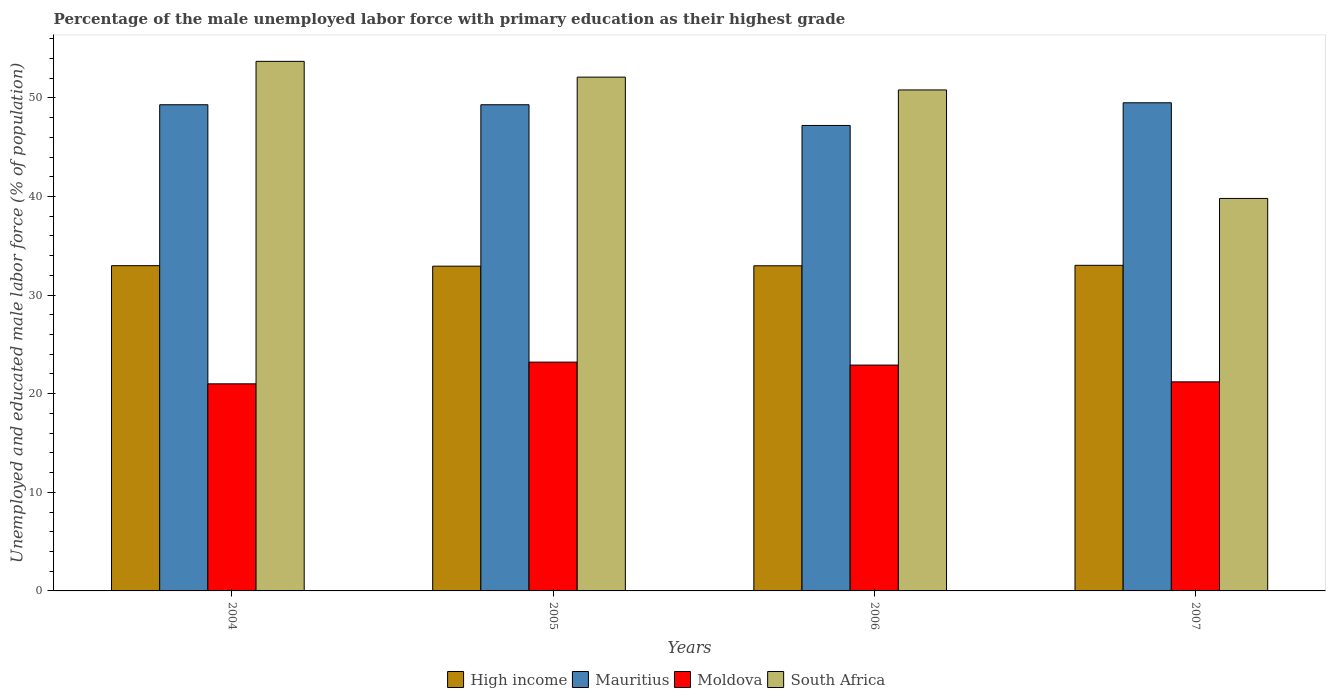Are the number of bars per tick equal to the number of legend labels?
Offer a very short reply. Yes. What is the percentage of the unemployed male labor force with primary education in South Africa in 2007?
Your answer should be compact. 39.8. Across all years, what is the maximum percentage of the unemployed male labor force with primary education in South Africa?
Your response must be concise. 53.7. Across all years, what is the minimum percentage of the unemployed male labor force with primary education in Mauritius?
Your response must be concise. 47.2. What is the total percentage of the unemployed male labor force with primary education in South Africa in the graph?
Give a very brief answer. 196.4. What is the difference between the percentage of the unemployed male labor force with primary education in South Africa in 2005 and that in 2007?
Your answer should be compact. 12.3. What is the difference between the percentage of the unemployed male labor force with primary education in South Africa in 2007 and the percentage of the unemployed male labor force with primary education in Mauritius in 2006?
Ensure brevity in your answer.  -7.4. What is the average percentage of the unemployed male labor force with primary education in South Africa per year?
Your answer should be compact. 49.1. In the year 2004, what is the difference between the percentage of the unemployed male labor force with primary education in South Africa and percentage of the unemployed male labor force with primary education in Mauritius?
Your response must be concise. 4.4. In how many years, is the percentage of the unemployed male labor force with primary education in High income greater than 12 %?
Provide a short and direct response. 4. What is the ratio of the percentage of the unemployed male labor force with primary education in Moldova in 2004 to that in 2006?
Offer a very short reply. 0.92. Is the difference between the percentage of the unemployed male labor force with primary education in South Africa in 2006 and 2007 greater than the difference between the percentage of the unemployed male labor force with primary education in Mauritius in 2006 and 2007?
Your answer should be very brief. Yes. What is the difference between the highest and the second highest percentage of the unemployed male labor force with primary education in Mauritius?
Provide a succinct answer. 0.2. What is the difference between the highest and the lowest percentage of the unemployed male labor force with primary education in High income?
Give a very brief answer. 0.09. In how many years, is the percentage of the unemployed male labor force with primary education in High income greater than the average percentage of the unemployed male labor force with primary education in High income taken over all years?
Provide a succinct answer. 2. Is it the case that in every year, the sum of the percentage of the unemployed male labor force with primary education in High income and percentage of the unemployed male labor force with primary education in Mauritius is greater than the sum of percentage of the unemployed male labor force with primary education in South Africa and percentage of the unemployed male labor force with primary education in Moldova?
Give a very brief answer. No. What does the 4th bar from the left in 2007 represents?
Offer a very short reply. South Africa. What does the 2nd bar from the right in 2004 represents?
Keep it short and to the point. Moldova. Are all the bars in the graph horizontal?
Provide a short and direct response. No. What is the difference between two consecutive major ticks on the Y-axis?
Provide a succinct answer. 10. Are the values on the major ticks of Y-axis written in scientific E-notation?
Your response must be concise. No. How many legend labels are there?
Give a very brief answer. 4. What is the title of the graph?
Offer a very short reply. Percentage of the male unemployed labor force with primary education as their highest grade. What is the label or title of the X-axis?
Offer a very short reply. Years. What is the label or title of the Y-axis?
Your response must be concise. Unemployed and educated male labor force (% of population). What is the Unemployed and educated male labor force (% of population) of High income in 2004?
Provide a short and direct response. 32.98. What is the Unemployed and educated male labor force (% of population) in Mauritius in 2004?
Make the answer very short. 49.3. What is the Unemployed and educated male labor force (% of population) in South Africa in 2004?
Provide a short and direct response. 53.7. What is the Unemployed and educated male labor force (% of population) in High income in 2005?
Your answer should be very brief. 32.93. What is the Unemployed and educated male labor force (% of population) in Mauritius in 2005?
Offer a very short reply. 49.3. What is the Unemployed and educated male labor force (% of population) of Moldova in 2005?
Make the answer very short. 23.2. What is the Unemployed and educated male labor force (% of population) in South Africa in 2005?
Provide a short and direct response. 52.1. What is the Unemployed and educated male labor force (% of population) of High income in 2006?
Give a very brief answer. 32.97. What is the Unemployed and educated male labor force (% of population) in Mauritius in 2006?
Your response must be concise. 47.2. What is the Unemployed and educated male labor force (% of population) in Moldova in 2006?
Offer a terse response. 22.9. What is the Unemployed and educated male labor force (% of population) of South Africa in 2006?
Provide a succinct answer. 50.8. What is the Unemployed and educated male labor force (% of population) of High income in 2007?
Keep it short and to the point. 33.02. What is the Unemployed and educated male labor force (% of population) in Mauritius in 2007?
Your response must be concise. 49.5. What is the Unemployed and educated male labor force (% of population) in Moldova in 2007?
Ensure brevity in your answer.  21.2. What is the Unemployed and educated male labor force (% of population) of South Africa in 2007?
Provide a short and direct response. 39.8. Across all years, what is the maximum Unemployed and educated male labor force (% of population) of High income?
Offer a very short reply. 33.02. Across all years, what is the maximum Unemployed and educated male labor force (% of population) in Mauritius?
Provide a short and direct response. 49.5. Across all years, what is the maximum Unemployed and educated male labor force (% of population) in Moldova?
Make the answer very short. 23.2. Across all years, what is the maximum Unemployed and educated male labor force (% of population) in South Africa?
Provide a short and direct response. 53.7. Across all years, what is the minimum Unemployed and educated male labor force (% of population) of High income?
Give a very brief answer. 32.93. Across all years, what is the minimum Unemployed and educated male labor force (% of population) of Mauritius?
Your answer should be compact. 47.2. Across all years, what is the minimum Unemployed and educated male labor force (% of population) in Moldova?
Keep it short and to the point. 21. Across all years, what is the minimum Unemployed and educated male labor force (% of population) in South Africa?
Make the answer very short. 39.8. What is the total Unemployed and educated male labor force (% of population) in High income in the graph?
Your answer should be compact. 131.9. What is the total Unemployed and educated male labor force (% of population) in Mauritius in the graph?
Give a very brief answer. 195.3. What is the total Unemployed and educated male labor force (% of population) in Moldova in the graph?
Provide a succinct answer. 88.3. What is the total Unemployed and educated male labor force (% of population) of South Africa in the graph?
Keep it short and to the point. 196.4. What is the difference between the Unemployed and educated male labor force (% of population) of High income in 2004 and that in 2005?
Make the answer very short. 0.05. What is the difference between the Unemployed and educated male labor force (% of population) in Moldova in 2004 and that in 2005?
Make the answer very short. -2.2. What is the difference between the Unemployed and educated male labor force (% of population) in South Africa in 2004 and that in 2005?
Keep it short and to the point. 1.6. What is the difference between the Unemployed and educated male labor force (% of population) in High income in 2004 and that in 2006?
Offer a very short reply. 0.01. What is the difference between the Unemployed and educated male labor force (% of population) in Mauritius in 2004 and that in 2006?
Your response must be concise. 2.1. What is the difference between the Unemployed and educated male labor force (% of population) in High income in 2004 and that in 2007?
Ensure brevity in your answer.  -0.04. What is the difference between the Unemployed and educated male labor force (% of population) of Mauritius in 2004 and that in 2007?
Keep it short and to the point. -0.2. What is the difference between the Unemployed and educated male labor force (% of population) in Moldova in 2004 and that in 2007?
Make the answer very short. -0.2. What is the difference between the Unemployed and educated male labor force (% of population) of South Africa in 2004 and that in 2007?
Your answer should be compact. 13.9. What is the difference between the Unemployed and educated male labor force (% of population) in High income in 2005 and that in 2006?
Provide a short and direct response. -0.04. What is the difference between the Unemployed and educated male labor force (% of population) in Moldova in 2005 and that in 2006?
Give a very brief answer. 0.3. What is the difference between the Unemployed and educated male labor force (% of population) of South Africa in 2005 and that in 2006?
Your answer should be very brief. 1.3. What is the difference between the Unemployed and educated male labor force (% of population) in High income in 2005 and that in 2007?
Provide a short and direct response. -0.09. What is the difference between the Unemployed and educated male labor force (% of population) of Moldova in 2005 and that in 2007?
Offer a very short reply. 2. What is the difference between the Unemployed and educated male labor force (% of population) in High income in 2006 and that in 2007?
Make the answer very short. -0.05. What is the difference between the Unemployed and educated male labor force (% of population) of Mauritius in 2006 and that in 2007?
Your answer should be very brief. -2.3. What is the difference between the Unemployed and educated male labor force (% of population) in High income in 2004 and the Unemployed and educated male labor force (% of population) in Mauritius in 2005?
Offer a very short reply. -16.32. What is the difference between the Unemployed and educated male labor force (% of population) in High income in 2004 and the Unemployed and educated male labor force (% of population) in Moldova in 2005?
Ensure brevity in your answer.  9.78. What is the difference between the Unemployed and educated male labor force (% of population) in High income in 2004 and the Unemployed and educated male labor force (% of population) in South Africa in 2005?
Your answer should be compact. -19.12. What is the difference between the Unemployed and educated male labor force (% of population) in Mauritius in 2004 and the Unemployed and educated male labor force (% of population) in Moldova in 2005?
Make the answer very short. 26.1. What is the difference between the Unemployed and educated male labor force (% of population) in Moldova in 2004 and the Unemployed and educated male labor force (% of population) in South Africa in 2005?
Your response must be concise. -31.1. What is the difference between the Unemployed and educated male labor force (% of population) in High income in 2004 and the Unemployed and educated male labor force (% of population) in Mauritius in 2006?
Ensure brevity in your answer.  -14.22. What is the difference between the Unemployed and educated male labor force (% of population) of High income in 2004 and the Unemployed and educated male labor force (% of population) of Moldova in 2006?
Give a very brief answer. 10.08. What is the difference between the Unemployed and educated male labor force (% of population) in High income in 2004 and the Unemployed and educated male labor force (% of population) in South Africa in 2006?
Provide a short and direct response. -17.82. What is the difference between the Unemployed and educated male labor force (% of population) of Mauritius in 2004 and the Unemployed and educated male labor force (% of population) of Moldova in 2006?
Your answer should be compact. 26.4. What is the difference between the Unemployed and educated male labor force (% of population) of Mauritius in 2004 and the Unemployed and educated male labor force (% of population) of South Africa in 2006?
Ensure brevity in your answer.  -1.5. What is the difference between the Unemployed and educated male labor force (% of population) of Moldova in 2004 and the Unemployed and educated male labor force (% of population) of South Africa in 2006?
Give a very brief answer. -29.8. What is the difference between the Unemployed and educated male labor force (% of population) of High income in 2004 and the Unemployed and educated male labor force (% of population) of Mauritius in 2007?
Make the answer very short. -16.52. What is the difference between the Unemployed and educated male labor force (% of population) in High income in 2004 and the Unemployed and educated male labor force (% of population) in Moldova in 2007?
Your response must be concise. 11.78. What is the difference between the Unemployed and educated male labor force (% of population) of High income in 2004 and the Unemployed and educated male labor force (% of population) of South Africa in 2007?
Your answer should be compact. -6.82. What is the difference between the Unemployed and educated male labor force (% of population) in Mauritius in 2004 and the Unemployed and educated male labor force (% of population) in Moldova in 2007?
Provide a short and direct response. 28.1. What is the difference between the Unemployed and educated male labor force (% of population) of Mauritius in 2004 and the Unemployed and educated male labor force (% of population) of South Africa in 2007?
Give a very brief answer. 9.5. What is the difference between the Unemployed and educated male labor force (% of population) of Moldova in 2004 and the Unemployed and educated male labor force (% of population) of South Africa in 2007?
Give a very brief answer. -18.8. What is the difference between the Unemployed and educated male labor force (% of population) of High income in 2005 and the Unemployed and educated male labor force (% of population) of Mauritius in 2006?
Offer a very short reply. -14.27. What is the difference between the Unemployed and educated male labor force (% of population) in High income in 2005 and the Unemployed and educated male labor force (% of population) in Moldova in 2006?
Offer a terse response. 10.03. What is the difference between the Unemployed and educated male labor force (% of population) in High income in 2005 and the Unemployed and educated male labor force (% of population) in South Africa in 2006?
Your answer should be compact. -17.87. What is the difference between the Unemployed and educated male labor force (% of population) in Mauritius in 2005 and the Unemployed and educated male labor force (% of population) in Moldova in 2006?
Ensure brevity in your answer.  26.4. What is the difference between the Unemployed and educated male labor force (% of population) in Moldova in 2005 and the Unemployed and educated male labor force (% of population) in South Africa in 2006?
Provide a succinct answer. -27.6. What is the difference between the Unemployed and educated male labor force (% of population) in High income in 2005 and the Unemployed and educated male labor force (% of population) in Mauritius in 2007?
Offer a very short reply. -16.57. What is the difference between the Unemployed and educated male labor force (% of population) in High income in 2005 and the Unemployed and educated male labor force (% of population) in Moldova in 2007?
Offer a very short reply. 11.73. What is the difference between the Unemployed and educated male labor force (% of population) of High income in 2005 and the Unemployed and educated male labor force (% of population) of South Africa in 2007?
Your answer should be very brief. -6.87. What is the difference between the Unemployed and educated male labor force (% of population) in Mauritius in 2005 and the Unemployed and educated male labor force (% of population) in Moldova in 2007?
Keep it short and to the point. 28.1. What is the difference between the Unemployed and educated male labor force (% of population) of Mauritius in 2005 and the Unemployed and educated male labor force (% of population) of South Africa in 2007?
Provide a succinct answer. 9.5. What is the difference between the Unemployed and educated male labor force (% of population) in Moldova in 2005 and the Unemployed and educated male labor force (% of population) in South Africa in 2007?
Make the answer very short. -16.6. What is the difference between the Unemployed and educated male labor force (% of population) in High income in 2006 and the Unemployed and educated male labor force (% of population) in Mauritius in 2007?
Offer a very short reply. -16.53. What is the difference between the Unemployed and educated male labor force (% of population) of High income in 2006 and the Unemployed and educated male labor force (% of population) of Moldova in 2007?
Provide a short and direct response. 11.77. What is the difference between the Unemployed and educated male labor force (% of population) of High income in 2006 and the Unemployed and educated male labor force (% of population) of South Africa in 2007?
Your answer should be compact. -6.83. What is the difference between the Unemployed and educated male labor force (% of population) of Mauritius in 2006 and the Unemployed and educated male labor force (% of population) of Moldova in 2007?
Your answer should be very brief. 26. What is the difference between the Unemployed and educated male labor force (% of population) in Mauritius in 2006 and the Unemployed and educated male labor force (% of population) in South Africa in 2007?
Give a very brief answer. 7.4. What is the difference between the Unemployed and educated male labor force (% of population) in Moldova in 2006 and the Unemployed and educated male labor force (% of population) in South Africa in 2007?
Your response must be concise. -16.9. What is the average Unemployed and educated male labor force (% of population) in High income per year?
Ensure brevity in your answer.  32.97. What is the average Unemployed and educated male labor force (% of population) of Mauritius per year?
Keep it short and to the point. 48.83. What is the average Unemployed and educated male labor force (% of population) in Moldova per year?
Your answer should be compact. 22.07. What is the average Unemployed and educated male labor force (% of population) of South Africa per year?
Your response must be concise. 49.1. In the year 2004, what is the difference between the Unemployed and educated male labor force (% of population) of High income and Unemployed and educated male labor force (% of population) of Mauritius?
Provide a short and direct response. -16.32. In the year 2004, what is the difference between the Unemployed and educated male labor force (% of population) of High income and Unemployed and educated male labor force (% of population) of Moldova?
Your answer should be very brief. 11.98. In the year 2004, what is the difference between the Unemployed and educated male labor force (% of population) of High income and Unemployed and educated male labor force (% of population) of South Africa?
Give a very brief answer. -20.72. In the year 2004, what is the difference between the Unemployed and educated male labor force (% of population) of Mauritius and Unemployed and educated male labor force (% of population) of Moldova?
Keep it short and to the point. 28.3. In the year 2004, what is the difference between the Unemployed and educated male labor force (% of population) in Mauritius and Unemployed and educated male labor force (% of population) in South Africa?
Provide a short and direct response. -4.4. In the year 2004, what is the difference between the Unemployed and educated male labor force (% of population) in Moldova and Unemployed and educated male labor force (% of population) in South Africa?
Make the answer very short. -32.7. In the year 2005, what is the difference between the Unemployed and educated male labor force (% of population) in High income and Unemployed and educated male labor force (% of population) in Mauritius?
Provide a short and direct response. -16.37. In the year 2005, what is the difference between the Unemployed and educated male labor force (% of population) in High income and Unemployed and educated male labor force (% of population) in Moldova?
Offer a very short reply. 9.73. In the year 2005, what is the difference between the Unemployed and educated male labor force (% of population) of High income and Unemployed and educated male labor force (% of population) of South Africa?
Keep it short and to the point. -19.17. In the year 2005, what is the difference between the Unemployed and educated male labor force (% of population) of Mauritius and Unemployed and educated male labor force (% of population) of Moldova?
Your response must be concise. 26.1. In the year 2005, what is the difference between the Unemployed and educated male labor force (% of population) of Moldova and Unemployed and educated male labor force (% of population) of South Africa?
Your answer should be compact. -28.9. In the year 2006, what is the difference between the Unemployed and educated male labor force (% of population) in High income and Unemployed and educated male labor force (% of population) in Mauritius?
Offer a terse response. -14.23. In the year 2006, what is the difference between the Unemployed and educated male labor force (% of population) of High income and Unemployed and educated male labor force (% of population) of Moldova?
Your answer should be very brief. 10.07. In the year 2006, what is the difference between the Unemployed and educated male labor force (% of population) in High income and Unemployed and educated male labor force (% of population) in South Africa?
Make the answer very short. -17.83. In the year 2006, what is the difference between the Unemployed and educated male labor force (% of population) of Mauritius and Unemployed and educated male labor force (% of population) of Moldova?
Provide a short and direct response. 24.3. In the year 2006, what is the difference between the Unemployed and educated male labor force (% of population) in Moldova and Unemployed and educated male labor force (% of population) in South Africa?
Keep it short and to the point. -27.9. In the year 2007, what is the difference between the Unemployed and educated male labor force (% of population) of High income and Unemployed and educated male labor force (% of population) of Mauritius?
Keep it short and to the point. -16.48. In the year 2007, what is the difference between the Unemployed and educated male labor force (% of population) of High income and Unemployed and educated male labor force (% of population) of Moldova?
Your response must be concise. 11.82. In the year 2007, what is the difference between the Unemployed and educated male labor force (% of population) in High income and Unemployed and educated male labor force (% of population) in South Africa?
Your answer should be compact. -6.78. In the year 2007, what is the difference between the Unemployed and educated male labor force (% of population) of Mauritius and Unemployed and educated male labor force (% of population) of Moldova?
Provide a short and direct response. 28.3. In the year 2007, what is the difference between the Unemployed and educated male labor force (% of population) in Moldova and Unemployed and educated male labor force (% of population) in South Africa?
Your response must be concise. -18.6. What is the ratio of the Unemployed and educated male labor force (% of population) in Moldova in 2004 to that in 2005?
Offer a terse response. 0.91. What is the ratio of the Unemployed and educated male labor force (% of population) in South Africa in 2004 to that in 2005?
Provide a succinct answer. 1.03. What is the ratio of the Unemployed and educated male labor force (% of population) of High income in 2004 to that in 2006?
Offer a terse response. 1. What is the ratio of the Unemployed and educated male labor force (% of population) of Mauritius in 2004 to that in 2006?
Your response must be concise. 1.04. What is the ratio of the Unemployed and educated male labor force (% of population) in Moldova in 2004 to that in 2006?
Make the answer very short. 0.92. What is the ratio of the Unemployed and educated male labor force (% of population) of South Africa in 2004 to that in 2006?
Give a very brief answer. 1.06. What is the ratio of the Unemployed and educated male labor force (% of population) of High income in 2004 to that in 2007?
Ensure brevity in your answer.  1. What is the ratio of the Unemployed and educated male labor force (% of population) of Mauritius in 2004 to that in 2007?
Ensure brevity in your answer.  1. What is the ratio of the Unemployed and educated male labor force (% of population) in Moldova in 2004 to that in 2007?
Ensure brevity in your answer.  0.99. What is the ratio of the Unemployed and educated male labor force (% of population) of South Africa in 2004 to that in 2007?
Provide a short and direct response. 1.35. What is the ratio of the Unemployed and educated male labor force (% of population) in High income in 2005 to that in 2006?
Make the answer very short. 1. What is the ratio of the Unemployed and educated male labor force (% of population) of Mauritius in 2005 to that in 2006?
Keep it short and to the point. 1.04. What is the ratio of the Unemployed and educated male labor force (% of population) of Moldova in 2005 to that in 2006?
Give a very brief answer. 1.01. What is the ratio of the Unemployed and educated male labor force (% of population) in South Africa in 2005 to that in 2006?
Provide a succinct answer. 1.03. What is the ratio of the Unemployed and educated male labor force (% of population) in Moldova in 2005 to that in 2007?
Offer a very short reply. 1.09. What is the ratio of the Unemployed and educated male labor force (% of population) in South Africa in 2005 to that in 2007?
Your answer should be compact. 1.31. What is the ratio of the Unemployed and educated male labor force (% of population) in Mauritius in 2006 to that in 2007?
Ensure brevity in your answer.  0.95. What is the ratio of the Unemployed and educated male labor force (% of population) of Moldova in 2006 to that in 2007?
Give a very brief answer. 1.08. What is the ratio of the Unemployed and educated male labor force (% of population) in South Africa in 2006 to that in 2007?
Keep it short and to the point. 1.28. What is the difference between the highest and the second highest Unemployed and educated male labor force (% of population) in High income?
Your response must be concise. 0.04. What is the difference between the highest and the second highest Unemployed and educated male labor force (% of population) of Mauritius?
Make the answer very short. 0.2. What is the difference between the highest and the second highest Unemployed and educated male labor force (% of population) in Moldova?
Give a very brief answer. 0.3. What is the difference between the highest and the lowest Unemployed and educated male labor force (% of population) of High income?
Offer a very short reply. 0.09. What is the difference between the highest and the lowest Unemployed and educated male labor force (% of population) of Mauritius?
Your answer should be compact. 2.3. 